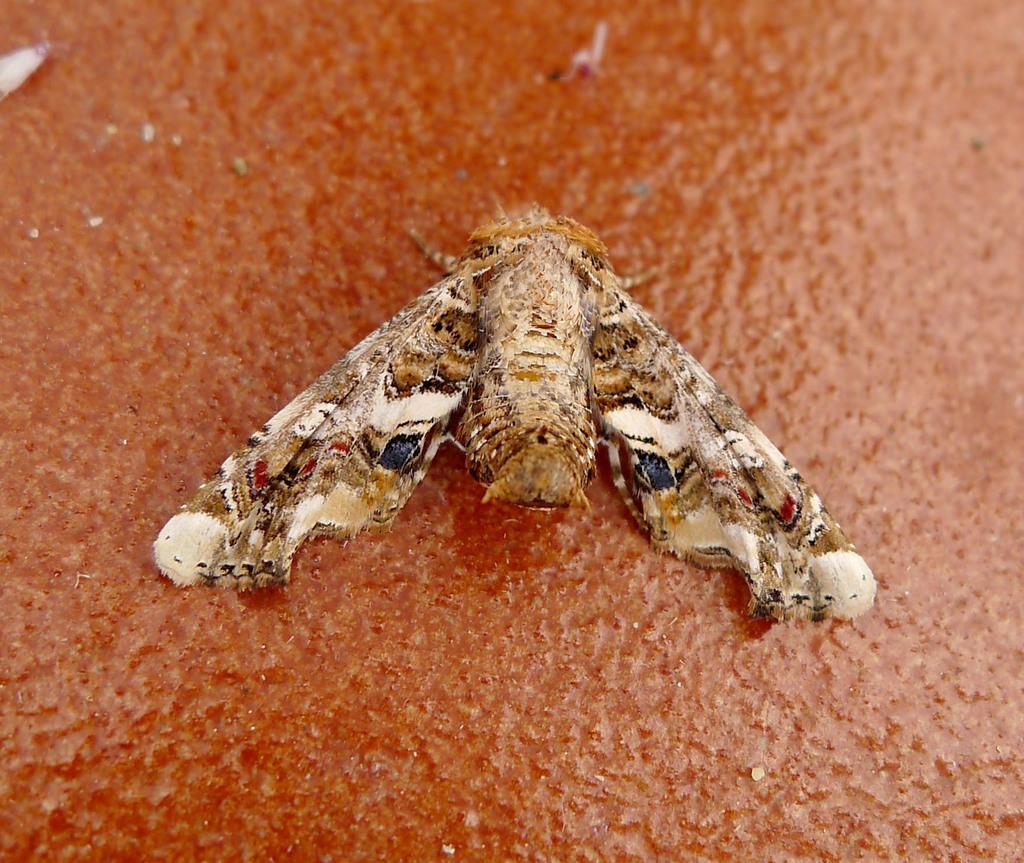How would you summarize this image in a sentence or two? In the middle of the image we can see a insect. 